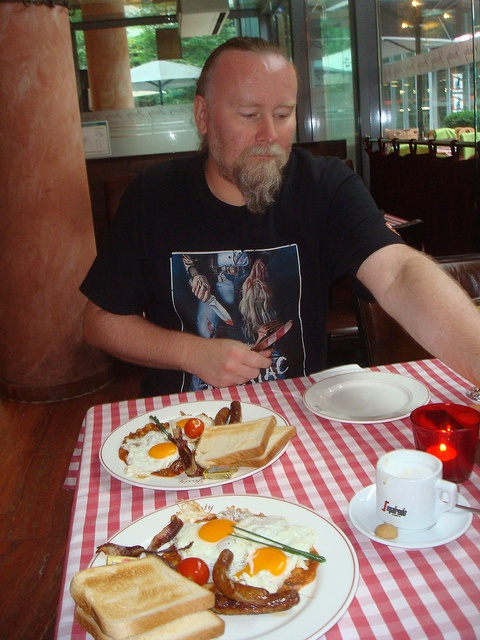Describe the objects in this image and their specific colors. I can see dining table in black, lightgray, maroon, brown, and darkgray tones, people in black, brown, maroon, and gray tones, cup in black, lightgray, darkgray, and gray tones, cup in black, maroon, red, and brown tones, and knife in black, maroon, brown, and gray tones in this image. 